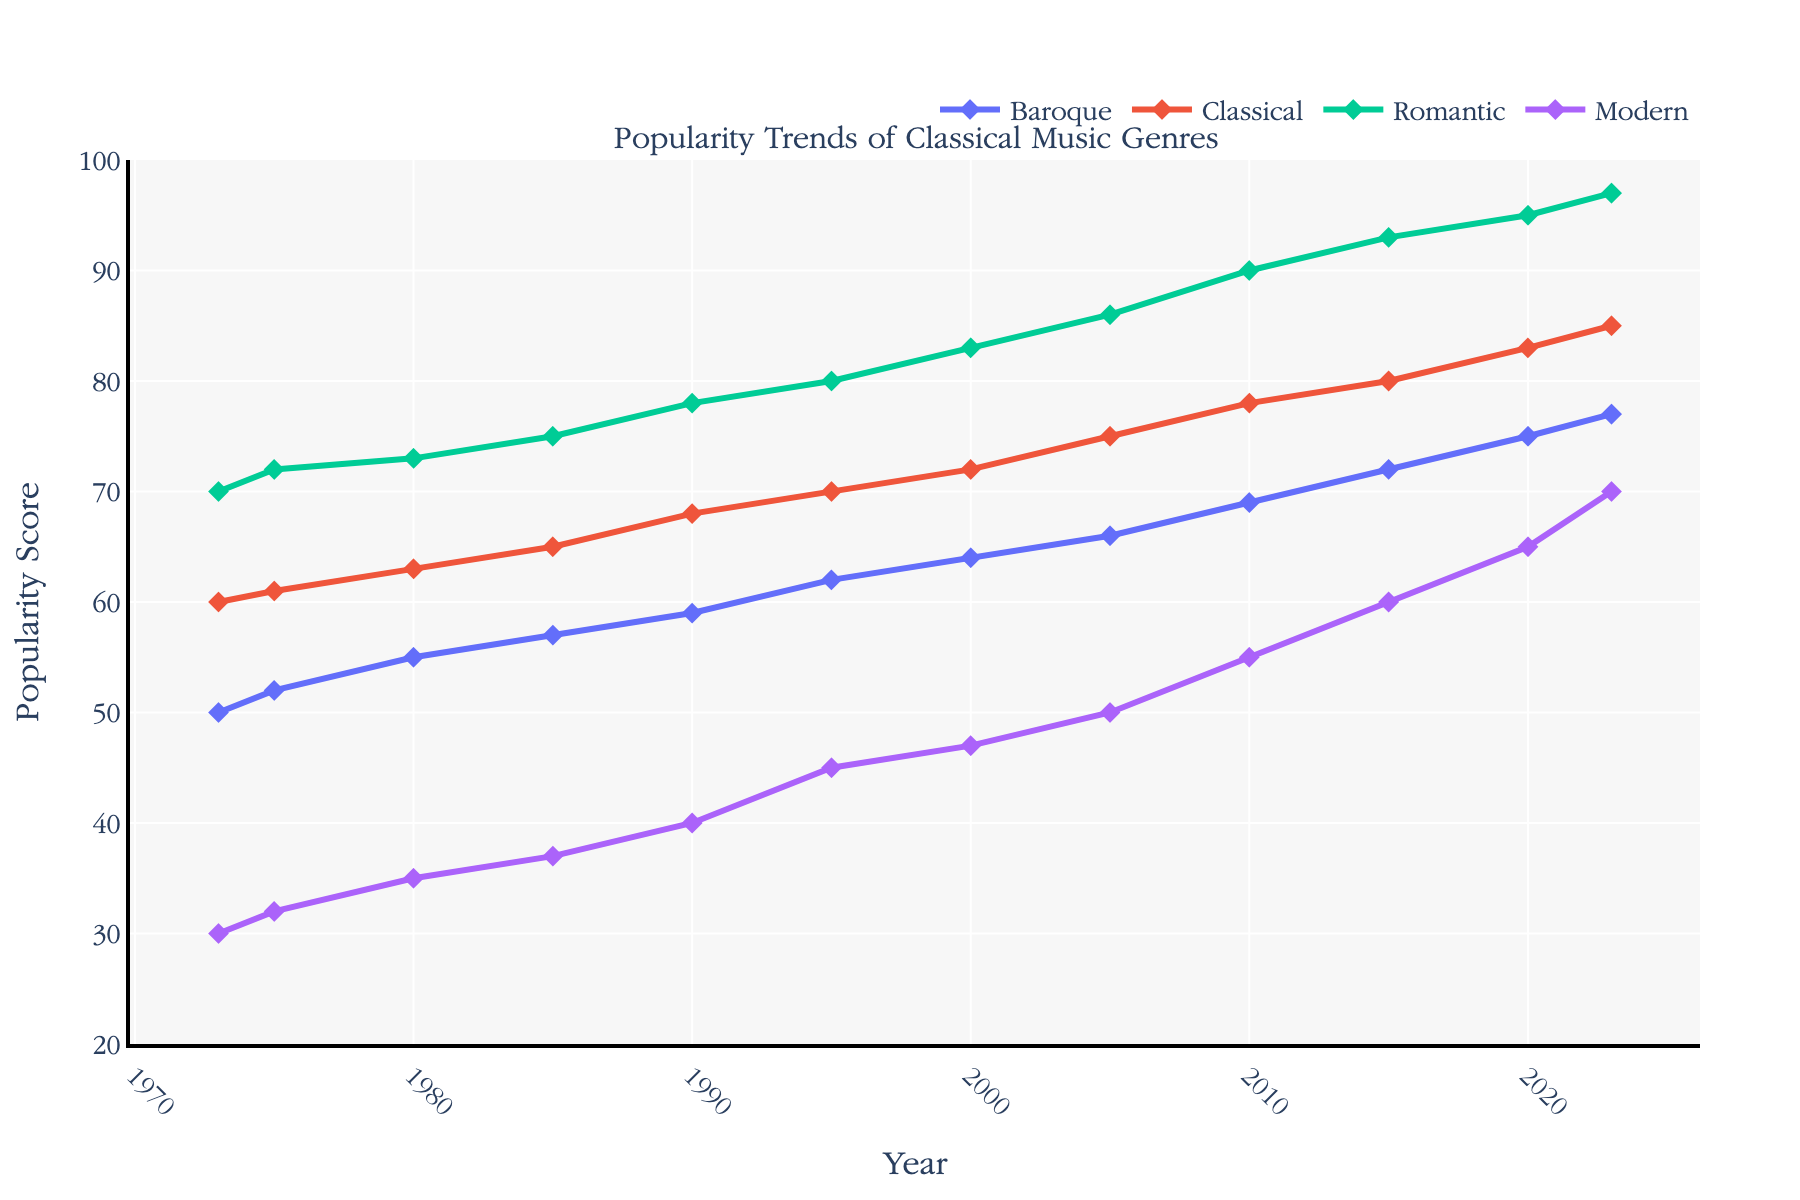Which genre had the highest popularity score in 2023? The figure shows the trends for four classical music genres. By comparing the values at the year 2023, we observe that the Romantic genre has the highest score among them.
Answer: Romantic What was the popularity score of the Modern genre in 1985? By looking at the point corresponding to the year 1985 on the Modern genre's trend line, we can see the popularity score. The Modern genre had a popularity score of 37 in 1985.
Answer: 37 How did the popularity of the Classical genre change from 2000 to 2005? By observing the Classical genre's trend line from the year 2000 to 2005, the popularity score increased from 72 to 75. The change in popularity is 75 - 72 = 3.
Answer: Increased by 3 Which two genres had equal popularity scores at any point in time? By visually inspecting the plot, we find that in the year 1995, both the Romantic and Modern genres had the same popularity score of 45.
Answer: Romantic and Modern What is the combined popularity score for the Baroque and Classical genres in 2020? The popularity scores for Baroque and Classical genres in 2020 are 75 and 83, respectively. Their combined score is 75 + 83 = 158.
Answer: 158 Which genre showed the most significant increase in popularity between 1973 and 2023? By comparing the scores in 2023 and 1973 for each genre, Romantic displayed the most significant increase, from 70 in 1973 to 97 in 2023, an increase of 27 points.
Answer: Romantic On average, what was the Romantic genre’s popularity every five years from 1973 to 2023? For every five-year period, the scores are: 70, 72, 73, 75, 78, 80, 83, 86, 90, 93, 95, 97. Summing these values gives 992. Dividing by 12 (number of data points) gives the average: 992/12 ≈ 82.67.
Answer: 82.67 In which year did the Baroque genre surpass a popularity score of 65? By following the Baroque genre's trend and looking for the first year it crosses 65, we identify the year 2005 as the point where it reached a score of 66.
Answer: 2005 